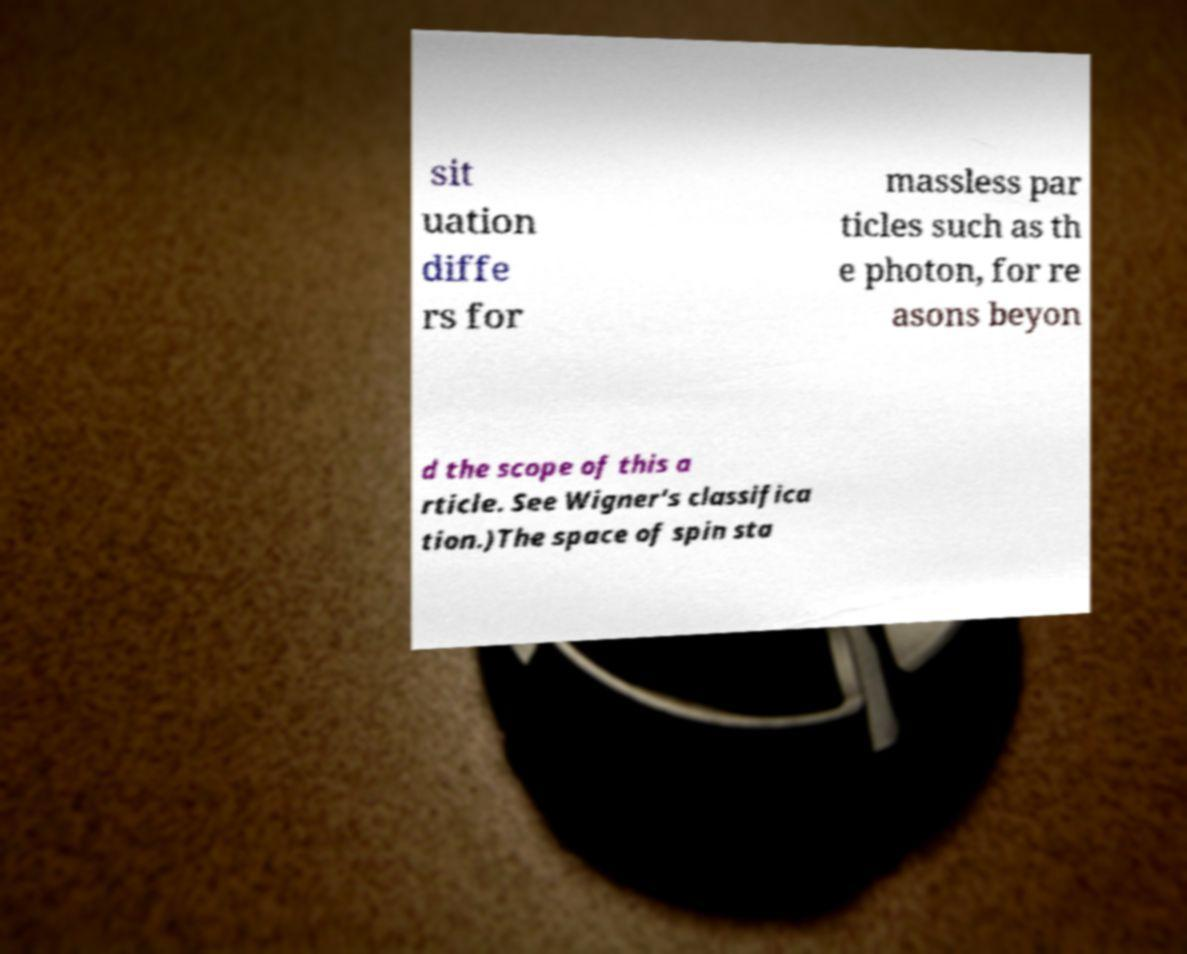I need the written content from this picture converted into text. Can you do that? sit uation diffe rs for massless par ticles such as th e photon, for re asons beyon d the scope of this a rticle. See Wigner's classifica tion.)The space of spin sta 